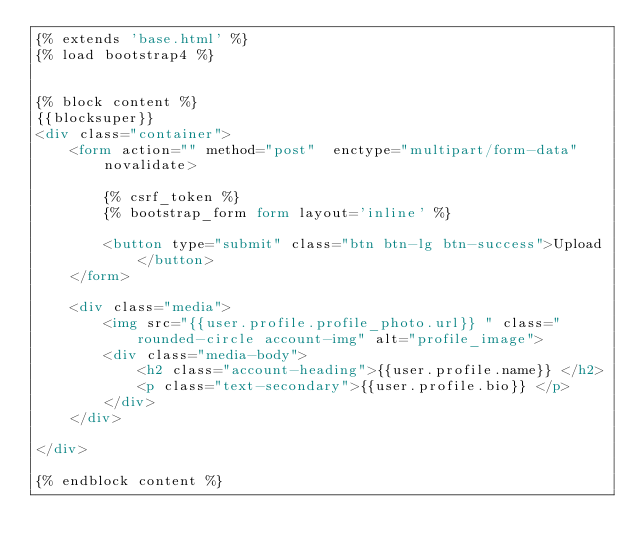Convert code to text. <code><loc_0><loc_0><loc_500><loc_500><_HTML_>{% extends 'base.html' %}
{% load bootstrap4 %}


{% block content %}
{{blocksuper}}
<div class="container">
    <form action="" method="post"  enctype="multipart/form-data" novalidate>

        {% csrf_token %}
        {% bootstrap_form form layout='inline' %}
       
        <button type="submit" class="btn btn-lg btn-success">Upload</button>
    </form>

    <div class="media">
        <img src="{{user.profile.profile_photo.url}} " class="rounded-circle account-img" alt="profile_image">
        <div class="media-body">
            <h2 class="account-heading">{{user.profile.name}} </h2>
            <p class="text-secondary">{{user.profile.bio}} </p>
        </div>
    </div>
    
</div>
    
{% endblock content %}
    </code> 